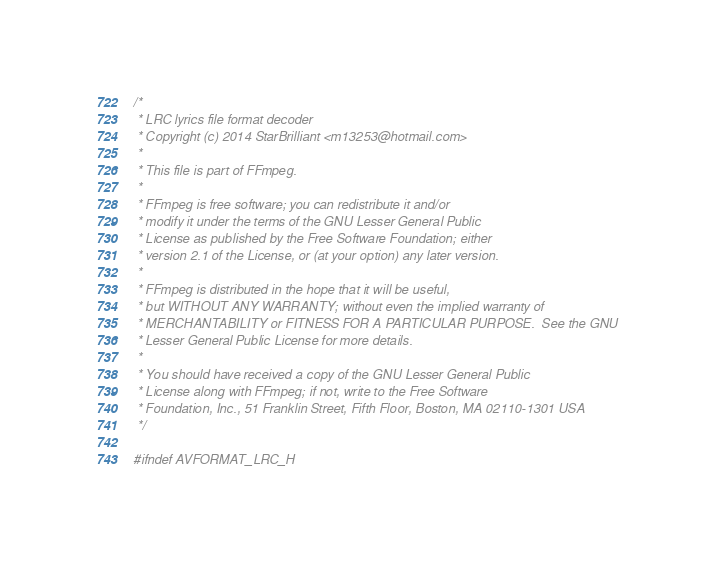<code> <loc_0><loc_0><loc_500><loc_500><_C_>/*
 * LRC lyrics file format decoder
 * Copyright (c) 2014 StarBrilliant <m13253@hotmail.com>
 *
 * This file is part of FFmpeg.
 *
 * FFmpeg is free software; you can redistribute it and/or
 * modify it under the terms of the GNU Lesser General Public
 * License as published by the Free Software Foundation; either
 * version 2.1 of the License, or (at your option) any later version.
 *
 * FFmpeg is distributed in the hope that it will be useful,
 * but WITHOUT ANY WARRANTY; without even the implied warranty of
 * MERCHANTABILITY or FITNESS FOR A PARTICULAR PURPOSE.  See the GNU
 * Lesser General Public License for more details.
 *
 * You should have received a copy of the GNU Lesser General Public
 * License along with FFmpeg; if not, write to the Free Software
 * Foundation, Inc., 51 Franklin Street, Fifth Floor, Boston, MA 02110-1301 USA
 */

#ifndef AVFORMAT_LRC_H</code> 